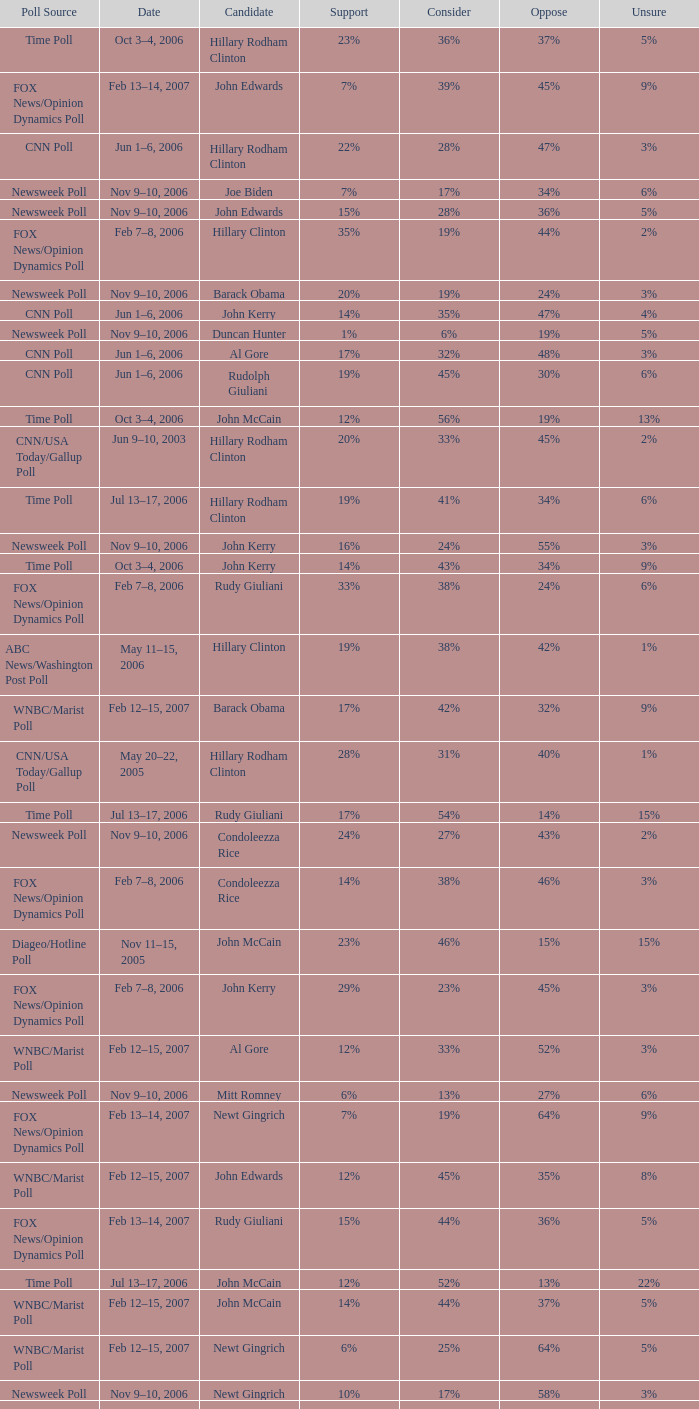What percentage of people were opposed to the candidate based on the WNBC/Marist poll that showed 8% of people were unsure? 35%. 